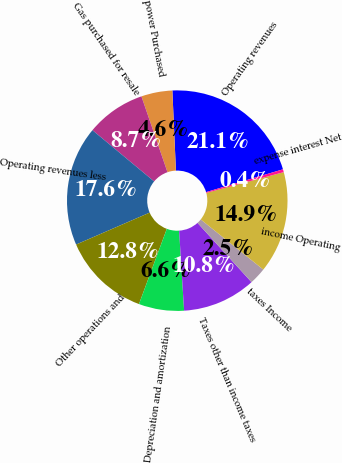<chart> <loc_0><loc_0><loc_500><loc_500><pie_chart><fcel>Operating revenues<fcel>power Purchased<fcel>Gas purchased for resale<fcel>Operating revenues less<fcel>Other operations and<fcel>Depreciation and amortization<fcel>Taxes other than income taxes<fcel>taxes Income<fcel>income Operating<fcel>expense interest Net<nl><fcel>21.12%<fcel>4.56%<fcel>8.7%<fcel>17.55%<fcel>12.84%<fcel>6.63%<fcel>10.77%<fcel>2.49%<fcel>14.91%<fcel>0.42%<nl></chart> 